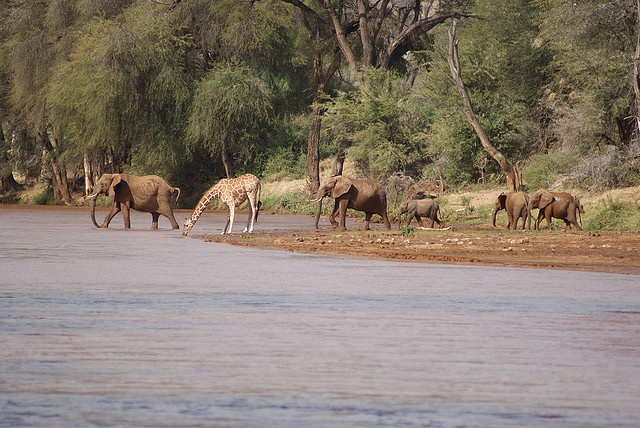Describe the objects in this image and their specific colors. I can see elephant in black, gray, maroon, and tan tones, elephant in black, gray, maroon, and tan tones, giraffe in black, gray, tan, and beige tones, elephant in black, gray, maroon, and tan tones, and elephant in black, gray, tan, and brown tones in this image. 